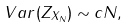<formula> <loc_0><loc_0><loc_500><loc_500>\ V a r ( Z _ { X _ { N } } ) \sim c N ,</formula> 